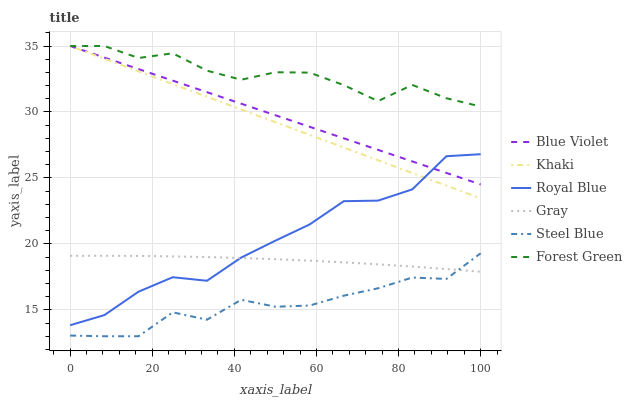Does Khaki have the minimum area under the curve?
Answer yes or no. No. Does Khaki have the maximum area under the curve?
Answer yes or no. No. Is Steel Blue the smoothest?
Answer yes or no. No. Is Khaki the roughest?
Answer yes or no. No. Does Khaki have the lowest value?
Answer yes or no. No. Does Steel Blue have the highest value?
Answer yes or no. No. Is Gray less than Blue Violet?
Answer yes or no. Yes. Is Forest Green greater than Royal Blue?
Answer yes or no. Yes. Does Gray intersect Blue Violet?
Answer yes or no. No. 